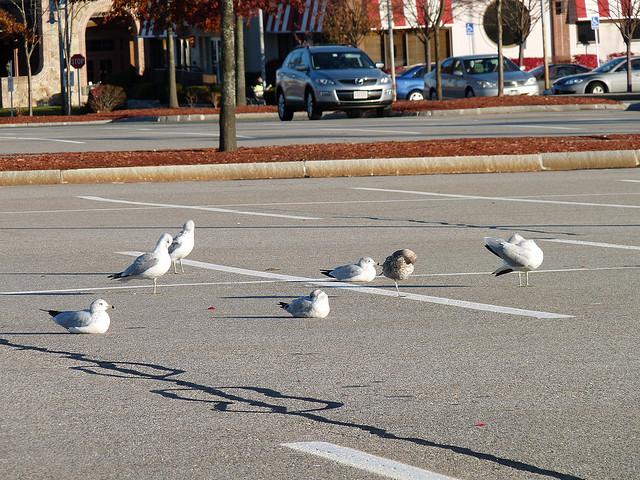Is there an SUV in this picture?
Answer briefly. Yes. What type of birds are on the street?
Concise answer only. Seagulls. Are the birds alive?
Short answer required. Yes. 